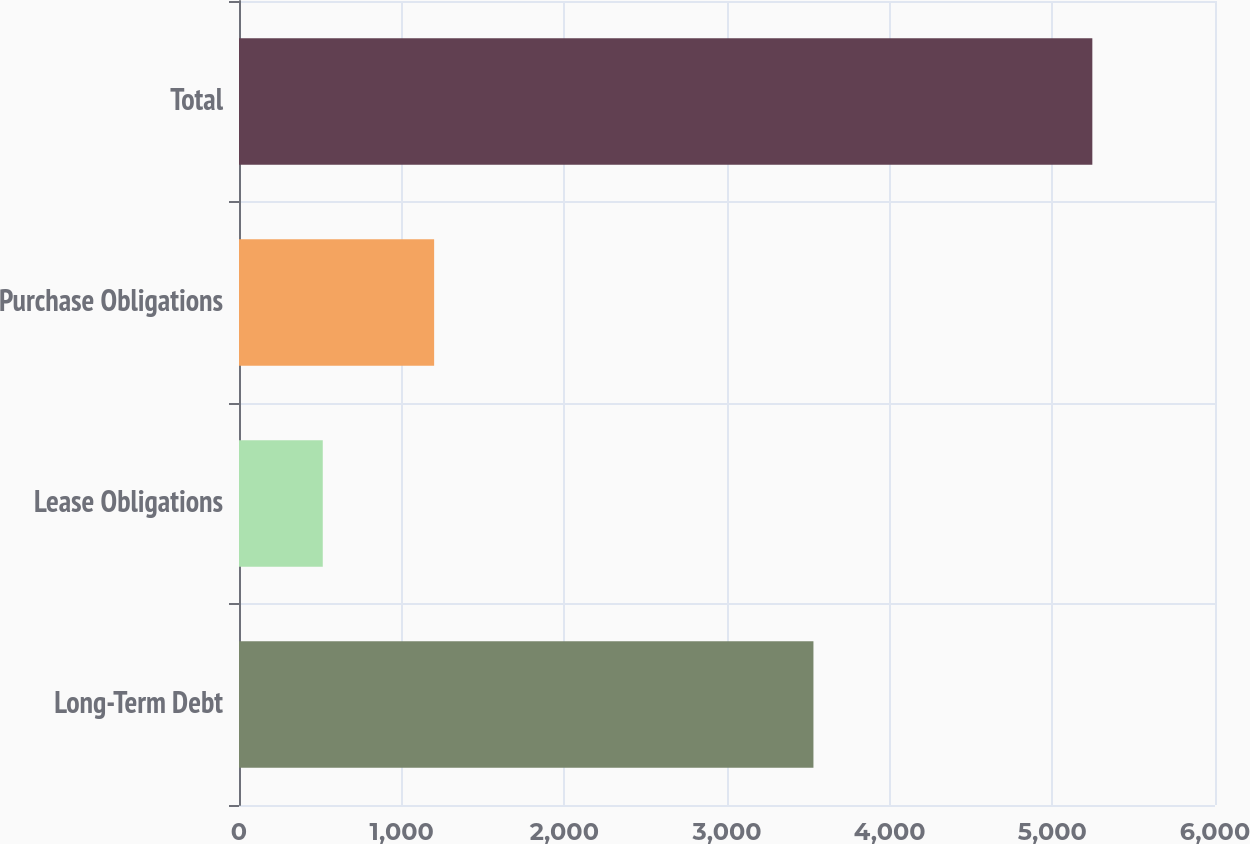Convert chart to OTSL. <chart><loc_0><loc_0><loc_500><loc_500><bar_chart><fcel>Long-Term Debt<fcel>Lease Obligations<fcel>Purchase Obligations<fcel>Total<nl><fcel>3531.4<fcel>514.9<fcel>1199.6<fcel>5245.9<nl></chart> 